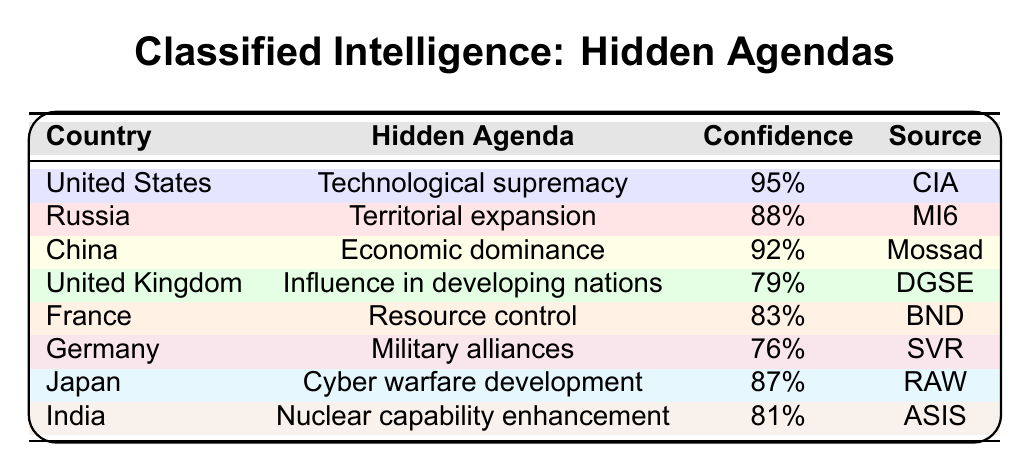What is the hidden agenda of the United Kingdom? The table indicates that the hidden agenda of the United Kingdom is "Influence in developing nations".
Answer: Influence in developing nations Which country has the highest confidence score in its hidden agenda? Upon reviewing the table, the United States has the highest confidence score of 95% regarding its agenda of "Technological supremacy".
Answer: United States Is the confidence level of Germany's hidden agenda higher than 80%? The table shows that Germany has a confidence level of 76%, which is below 80%.
Answer: No What is the average confidence score of the hidden agendas listed? To find the average, we sum up all the confidence scores: (95 + 88 + 92 + 79 + 83 + 76 + 87 + 81) =  601. There are 8 countries, so the average is 601/8 = 75.125.
Answer: 75.125 Which country is associated with the agenda of "Cyber warfare development"? The table specifies that Japan is associated with the agenda of "Cyber warfare development".
Answer: Japan How many countries have a confidence score above 85%? By examining the table, we see that the United States (95%), China (92%), Japan (87%), and India (81%) fall within this category. Therefore, 4 countries have a confidence score above 85%.
Answer: 4 Is France focused on military alliances according to the table? The data indicates that France's hidden agenda is "Resource control", not military alliances.
Answer: No What is the hidden agenda of Russia, and how confident is the source about it? According to the table, Russia's hidden agenda is "Territorial expansion", with a confidence score of 88% from the source MI6.
Answer: Territorial expansion, 88% Which countries have hidden agendas related to economic matters? The hidden agendas related to economic matters are those of the United States ("Technological supremacy") and China ("Economic dominance").
Answer: United States, China If we compare the confidence levels of the United States and Germany, what can we conclude? The United States has a confidence level of 95%, while Germany has a confidence level of 76%. This indicates that the United States is much more confident in its hidden agenda than Germany is.
Answer: The United States is more confident What percentage of countries have a hidden agenda of territorial expansion? Only one country, Russia, has "Territorial expansion" as its hidden agenda, which represents 1 out of 8 countries, or 12.5%.
Answer: 12.5% 